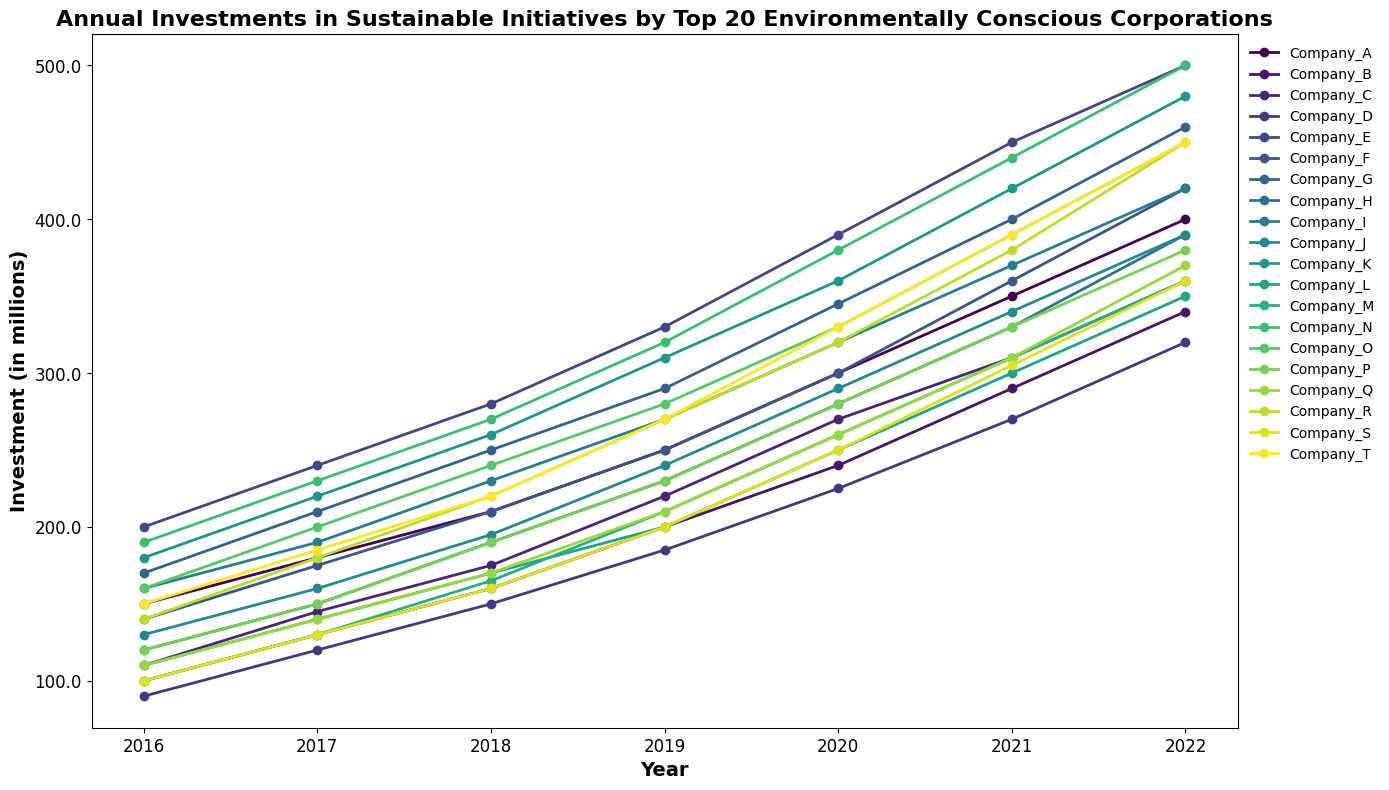What's the total investment made by Company_A from 2016 to 2022? To find the total investment made by Company_A from 2016 to 2022, sum all the investment values for the given years: 150 + 180 + 210 + 250 + 300 + 350 + 400 = 1840.
Answer: 1840 Between Companies F and G, which had a higher investment in 2020, and by how much? To compare the investments, find the investment values for Company_F and Company_G in 2020: Company_F had 300, and Company_G had 345. The difference is 345 - 300 = 45.
Answer: Company_G, by 45 Which company had the highest investment in 2019? From the figure, find the investment values for all companies in 2019. The highest investment is 330 by Company_E.
Answer: Company_E By how much did Company_K's investment increase from 2016 to 2022? Subtract the investment in 2016 from the investment in 2022 for Company_K: 480 - 180 = 300.
Answer: 300 What's the average investment in 2021 across all companies? Sum the investments for all companies in 2021 and then divide by the number of companies: (350 + 290 + 310 + 270 + 450 + 360 + 400 + 330 + 370 + 340 + 420 + 300 + 310 + 440 + 390 + 330 + 310 + 380 + 305 + 390) / 20. The total is 7385, so the average is 7385 / 20 = 369.25.
Answer: 369.25 Which company shows the most constant growth in investments from 2016 to 2022? Observe the lines in the figure and look for the company with evenly spaced data points over the years, showing a consistent trend. Company_A shows a fairly linear increase in investments each year.
Answer: Company_A How much more did Company_N invest in 2022 compared to Company_O? Find the investment amounts for both Company_N (500) and Company_O (450) in 2022, then subtract: 500 - 450 = 50.
Answer: 50 What's the trend in Company_T's investment over the entire period? Look at Company_T’s line from 2016 to 2022. The investment increases every year, indicating a consistent upward trend in investments.
Answer: Increasing trend Which company had the lowest investment in 2018? Find the investment values for all companies in 2018 and identify the lowest one. Company_B and Company_S both had the lowest investments at 160.
Answer: Company_B, Company_S What's the combined investment of companies C and H in 2017? Sum the investments of Company_C and Company_H in 2017: 145 (C) + 150 (H) = 295.
Answer: 295 